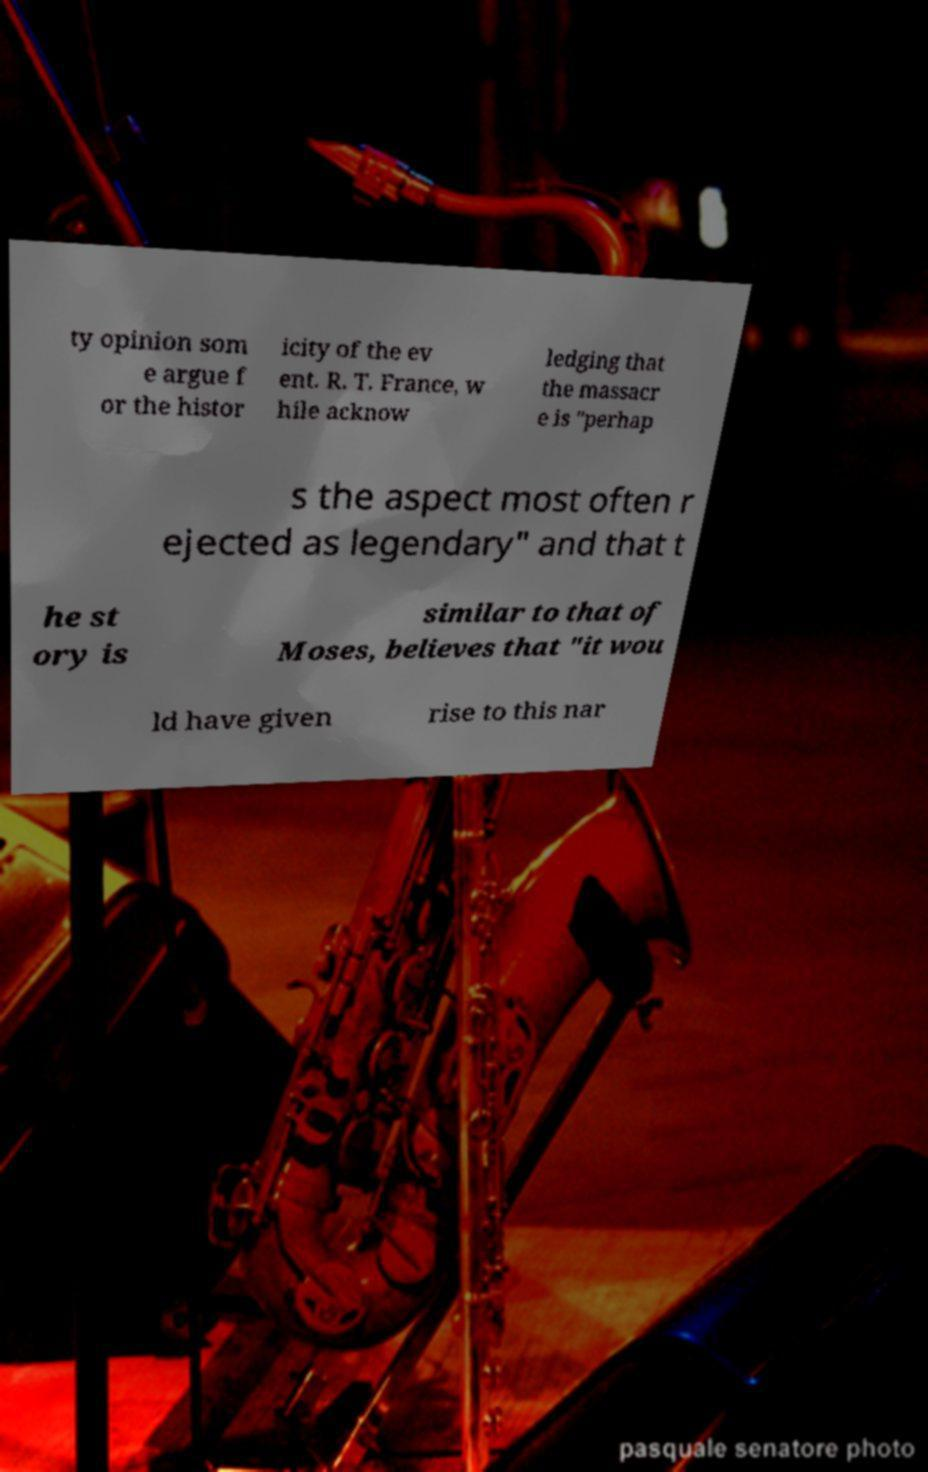Can you accurately transcribe the text from the provided image for me? ty opinion som e argue f or the histor icity of the ev ent. R. T. France, w hile acknow ledging that the massacr e is "perhap s the aspect most often r ejected as legendary" and that t he st ory is similar to that of Moses, believes that "it wou ld have given rise to this nar 